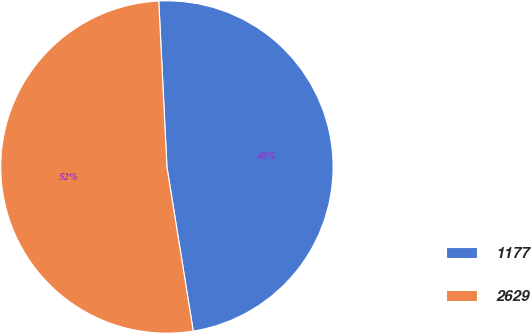Convert chart. <chart><loc_0><loc_0><loc_500><loc_500><pie_chart><fcel>1177<fcel>2629<nl><fcel>48.25%<fcel>51.75%<nl></chart> 